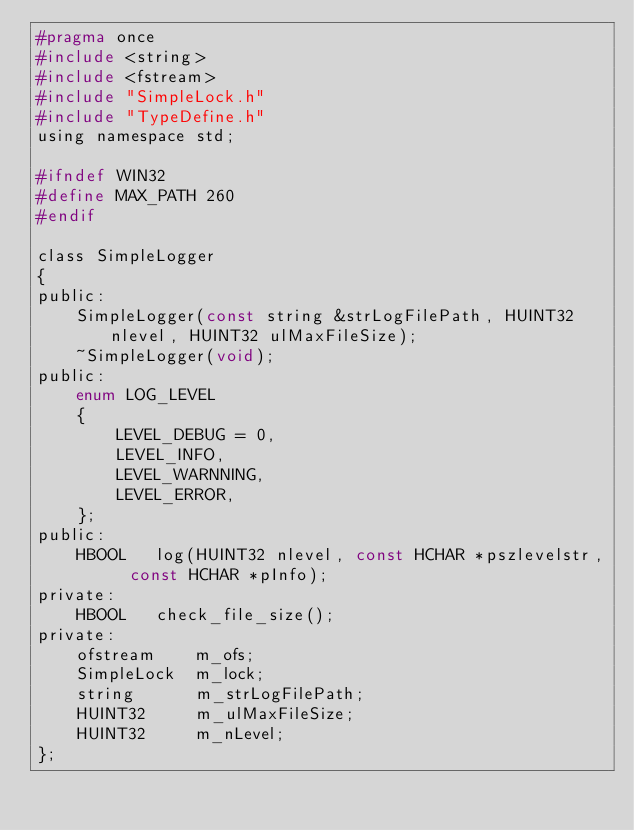Convert code to text. <code><loc_0><loc_0><loc_500><loc_500><_C_>#pragma once
#include <string>
#include <fstream>
#include "SimpleLock.h"
#include "TypeDefine.h"
using namespace std;

#ifndef WIN32
#define MAX_PATH 260
#endif

class SimpleLogger
{
public:
	SimpleLogger(const string &strLogFilePath, HUINT32 nlevel, HUINT32 ulMaxFileSize);
	~SimpleLogger(void);
public:
	enum LOG_LEVEL
	{
		LEVEL_DEBUG = 0,
		LEVEL_INFO,
		LEVEL_WARNNING,
		LEVEL_ERROR,
	};
public:
	HBOOL	log(HUINT32 nlevel, const HCHAR *pszlevelstr,  const HCHAR *pInfo);
private:
	HBOOL	check_file_size();
private:
	ofstream	m_ofs;
	SimpleLock	m_lock;
	string		m_strLogFilePath;
	HUINT32		m_ulMaxFileSize;
	HUINT32		m_nLevel;
};
</code> 